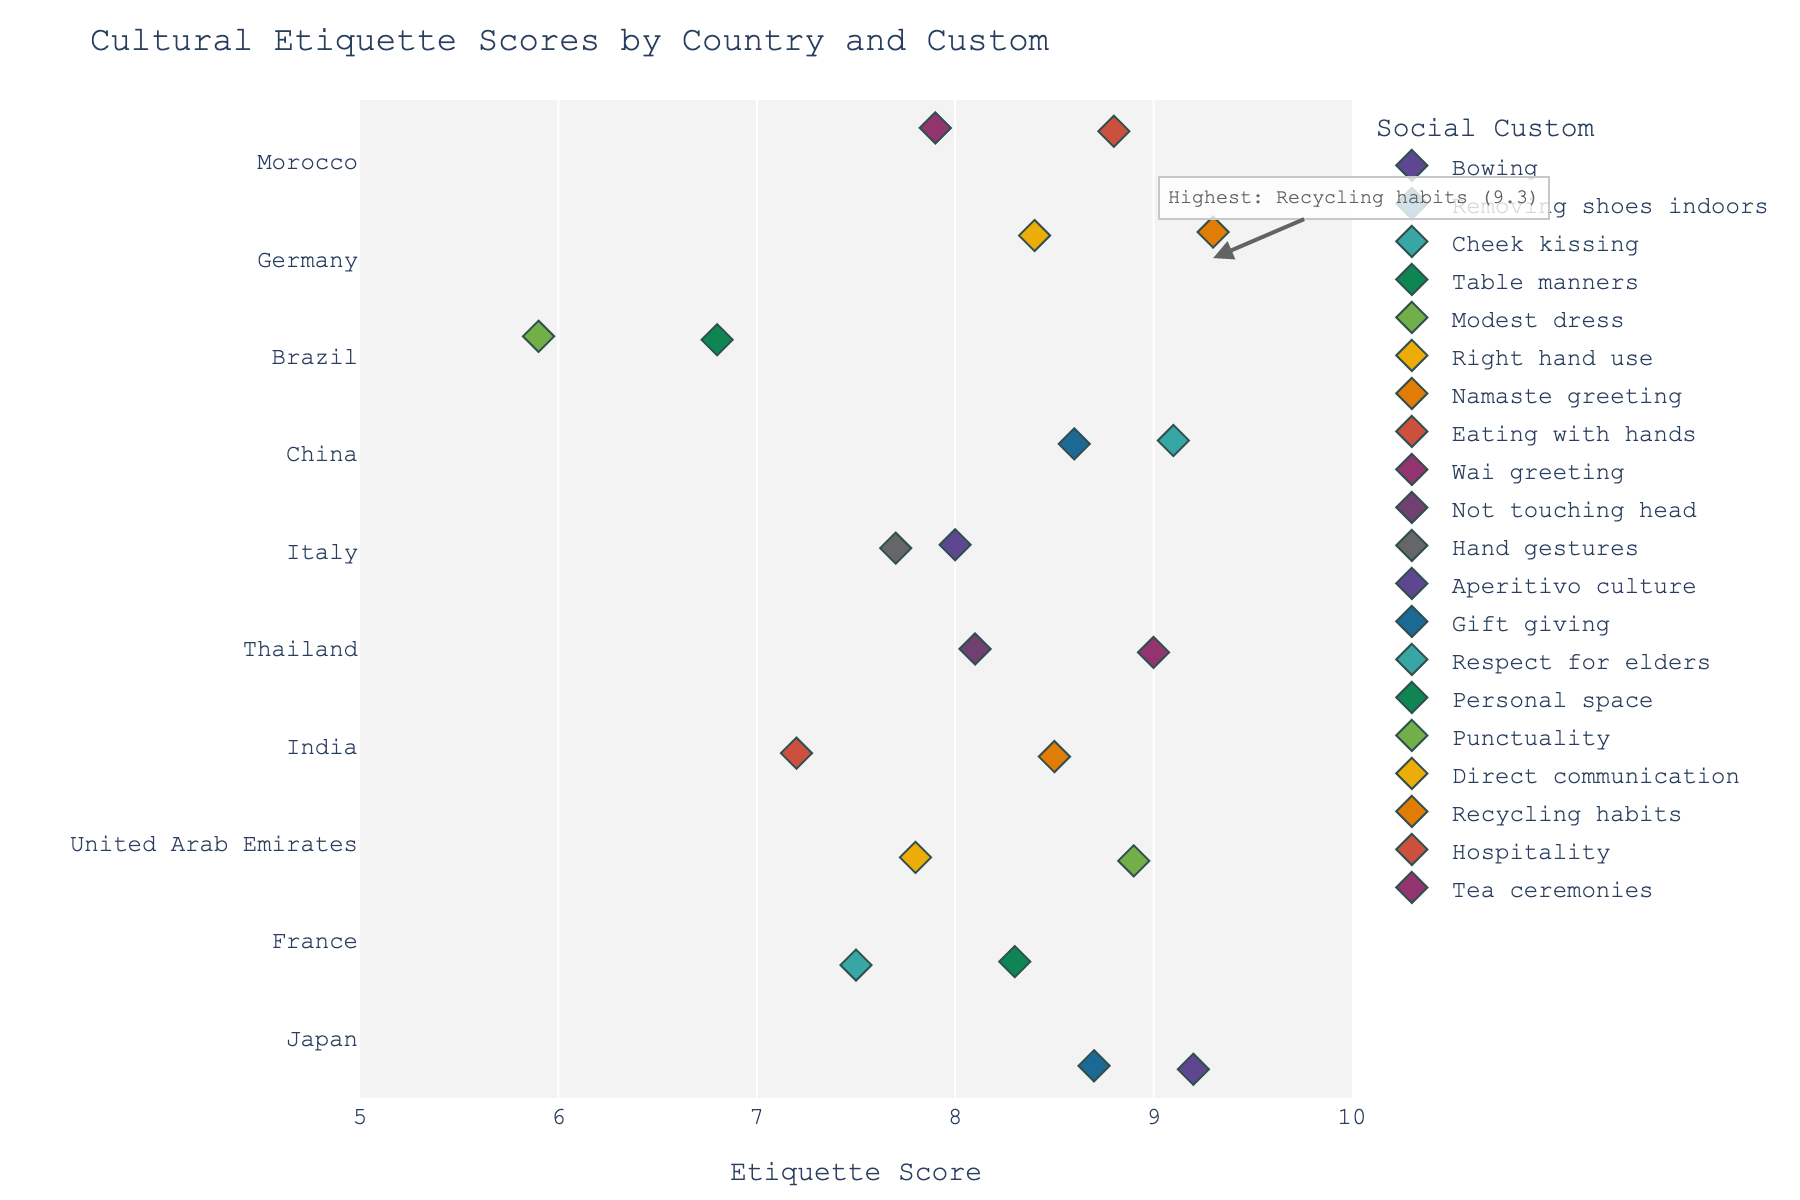How many countries are represented in the figure? Count all unique countries listed on the y-axis of the plot. There are: Japan, France, United Arab Emirates, India, Thailand, Italy, China, Brazil, Germany, Morocco.
Answer: 10 Which country has the highest etiquette score, and what is the corresponding custom? Look for the annotated point indicating the highest score. The annotation highlights the country and the custom with the highest score.
Answer: Germany, Recycling habits What is the average score of the customs in France? Find and sum the scores for France's customs: Cheek kissing (7.5) and Table manners (8.3), then divide by the number of customs (2). (7.5 + 8.3) / 2 = 7.9
Answer: 7.9 Which country has the lowest etiquette score, and what is the custom? Identify the lowest point on the x-axis and check its corresponding y-axis (country) and hover data (custom). It is Brazil with a score of 5.9 for Punctuality.
Answer: Brazil, Punctuality How many customs in the figure have a score of 9.0 or higher? Count the diamonds with a score of 9.0 or above on the x-axis. They belong to: Bowing, Wai greeting, Respect for elders, Recycling habits.
Answer: 4 Between Italy and China, which country has a higher average score of their customs? For Italy: Hand gestures (7.7) and Aperitivo culture (8.0), average is (7.7 + 8.0) / 2 = 7.85. For China: Gift giving (8.6) and Respect for elders (9.1), average is (8.6 + 9.1) / 2 = 8.85.
Answer: China Which custom represents India with the highest score? Locate the two customs for India and compare their scores: Namaste greeting (8.5) and Eating with hands (7.2). The highest score is for Namaste greeting.
Answer: Namaste greeting Are there any countries where the customs have the same score? Scan the plot for countries where multiple customs align vertically at the same x-axis point. There are no countries with customs having identical scores.
Answer: No What is the range of scores for customs in Morocco? Identify the highest and the lowest scores for Morocco: Hospitality (8.8) and Tea ceremonies (7.9). The range is 8.8 - 7.9 = 0.9.
Answer: 0.9 Which country has the most diverse (widely spread) scores for its customs? Check the spread of scores for each country. Brazil has the widest spread with scores of: Punctuality (5.9) and Personal space (6.8), the difference is 6.8 - 5.9 = 0.9.
Answer: Brazil 